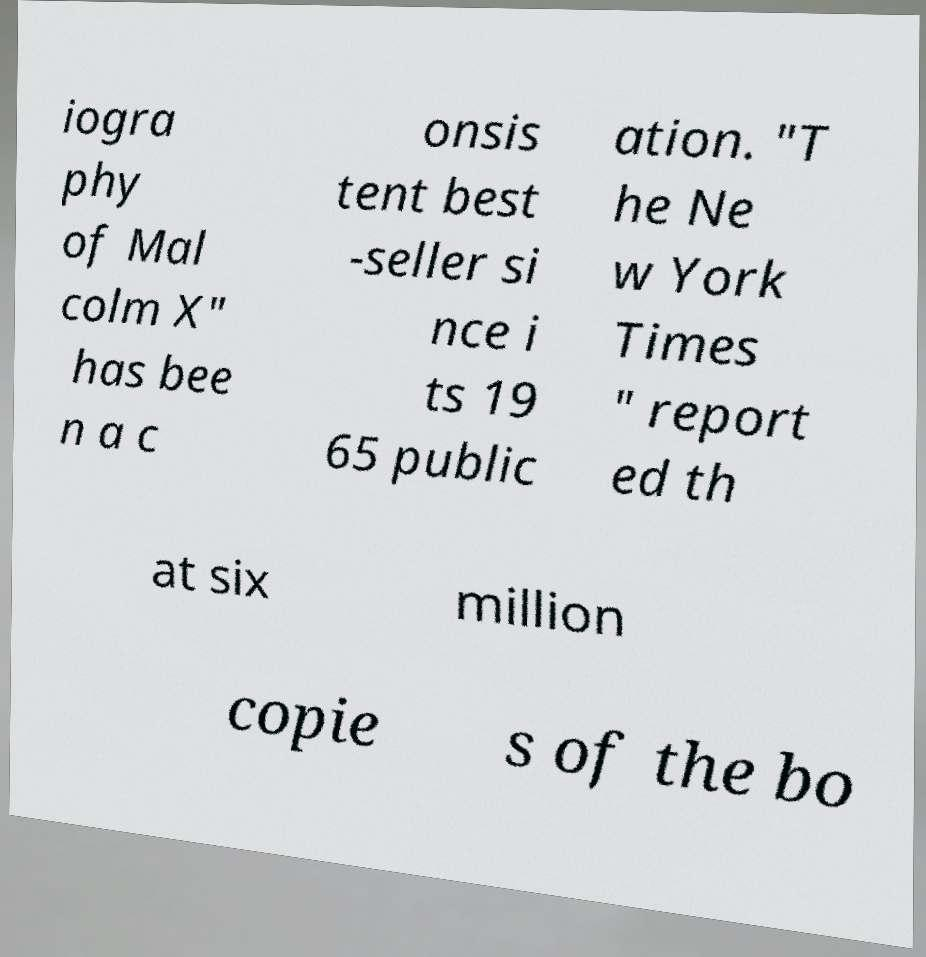What messages or text are displayed in this image? I need them in a readable, typed format. iogra phy of Mal colm X" has bee n a c onsis tent best -seller si nce i ts 19 65 public ation. "T he Ne w York Times " report ed th at six million copie s of the bo 